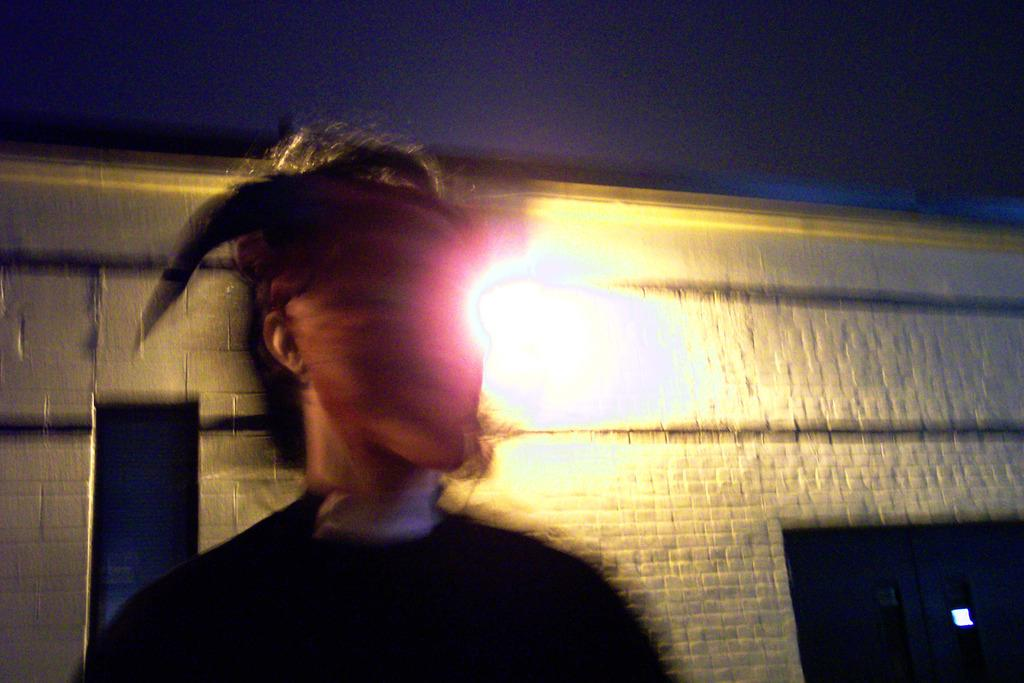Who or what is present in the image? There is a person in the image. What type of structure can be seen in the image? There is a building in the image. Can you describe the lighting conditions in the image? There is light in the image. What can be seen in the distance in the image? The sky is visible in the background of the image. What type of force is being exerted by the toad in the image? There is no toad present in the image, so it is not possible to determine what type of force might be exerted. 